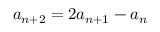<formula> <loc_0><loc_0><loc_500><loc_500>a _ { n + 2 } = 2 a _ { n + 1 } - a _ { n }</formula> 